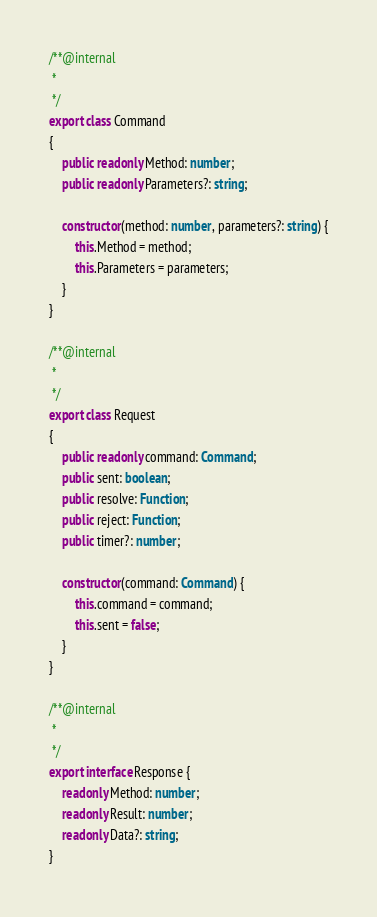<code> <loc_0><loc_0><loc_500><loc_500><_TypeScript_>/**@internal
 *
 */
export class Command
{
    public readonly Method: number;
    public readonly Parameters?: string;

    constructor(method: number, parameters?: string) {
        this.Method = method;
        this.Parameters = parameters;
    }
}

/**@internal
 *
 */
export class Request
{
    public readonly command: Command;
    public sent: boolean;
    public resolve: Function;
    public reject: Function;
    public timer?: number;

    constructor(command: Command) {
        this.command = command;
        this.sent = false;
    }
}

/**@internal
 *
 */
export interface Response {
    readonly Method: number;
    readonly Result: number;
    readonly Data?: string;
}
</code> 